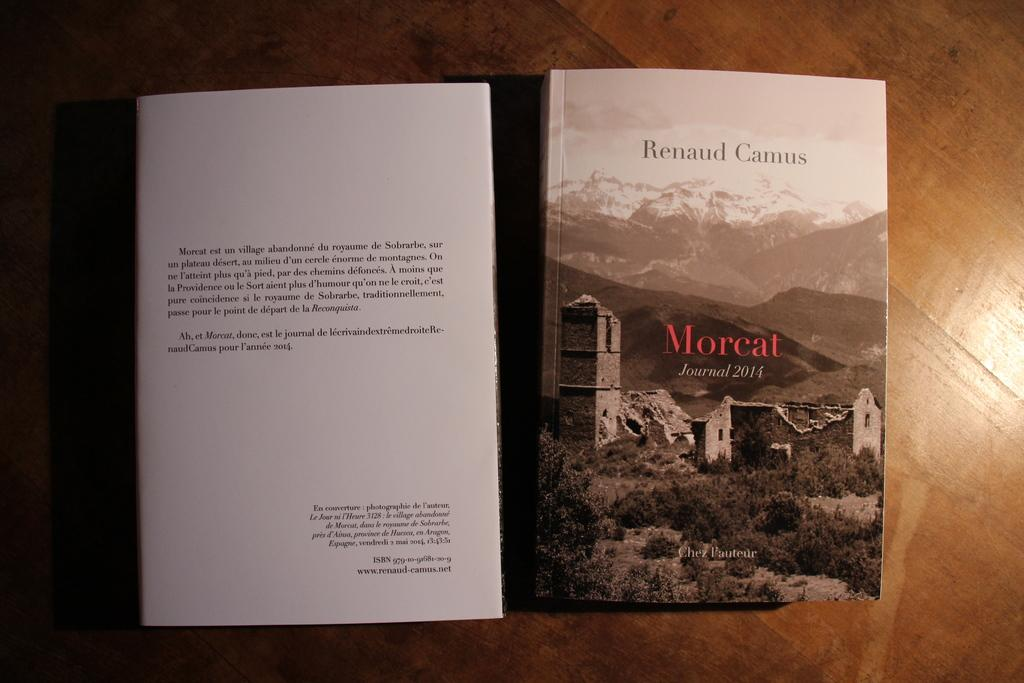<image>
Render a clear and concise summary of the photo. Book cover for Morcat by Renaud Camus showing a landscape on the cover. 